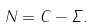<formula> <loc_0><loc_0><loc_500><loc_500>N = C - \varSigma .</formula> 